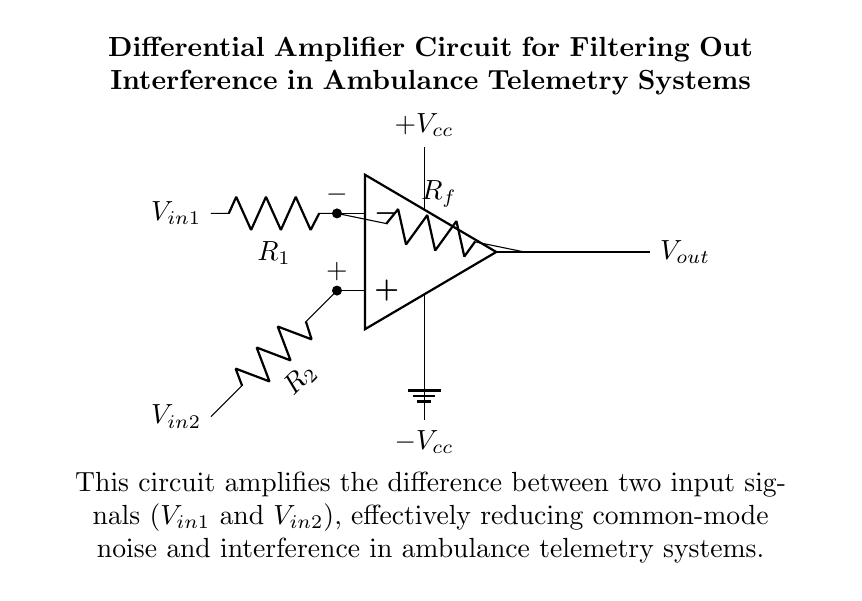What is the power supply voltage labeled in the diagram? The power supply voltage is labeled as "Vcc" for the positive voltage and "-Vcc" for the negative voltage. These represent the power supply connections to the operational amplifier, indicating a dual power supply setup.
Answer: Vcc, -Vcc What are the input resistors labeled in the circuit? The input resistors are labeled as "R1" and "R2" connected to the negative and positive terminals of the operational amplifier, respectively. These resistors determine the input impedance and the gain of the amplifier.
Answer: R1, R2 What type of amplifier is depicted in the circuit? The circuit in the diagram is a differential amplifier, which amplifies the difference between two input voltage signals while rejecting any common-mode signals or noise.
Answer: Differential amplifier How many operational amplifier inputs are there in this circuit? There are two inputs labeled as the inverting input and the non-inverting input, which correspond to the negative and positive terminals of the operational amplifier. Both inputs are necessary for the differential operation of the amplifier.
Answer: Two What is the purpose of the feedback resistor in this circuit? The feedback resistor, labeled "Rf," is used to control the gain of the differential amplifier. It helps set the relationship between the output voltage and the input voltage difference by providing feedback to the inverting input.
Answer: To set gain What is the function of the ground in this circuit? The ground in the circuit serves as the reference point for all voltage measurements and ensures the stability of the circuit. It provides a common return path for the electrical current, enhancing safety and functionality.
Answer: Reference point 